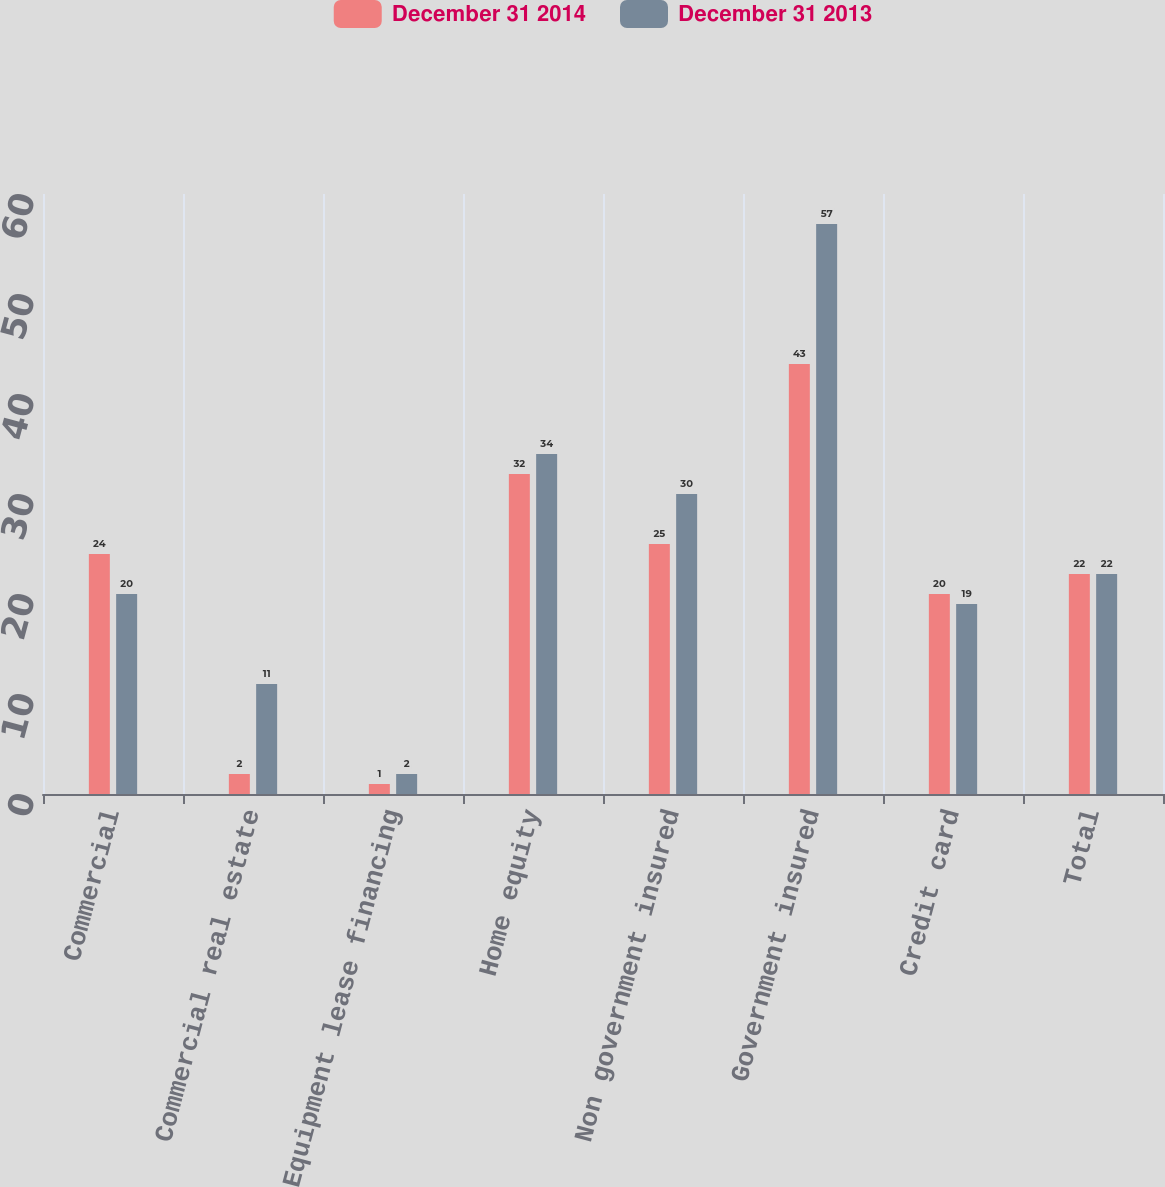Convert chart. <chart><loc_0><loc_0><loc_500><loc_500><stacked_bar_chart><ecel><fcel>Commercial<fcel>Commercial real estate<fcel>Equipment lease financing<fcel>Home equity<fcel>Non government insured<fcel>Government insured<fcel>Credit card<fcel>Total<nl><fcel>December 31 2014<fcel>24<fcel>2<fcel>1<fcel>32<fcel>25<fcel>43<fcel>20<fcel>22<nl><fcel>December 31 2013<fcel>20<fcel>11<fcel>2<fcel>34<fcel>30<fcel>57<fcel>19<fcel>22<nl></chart> 